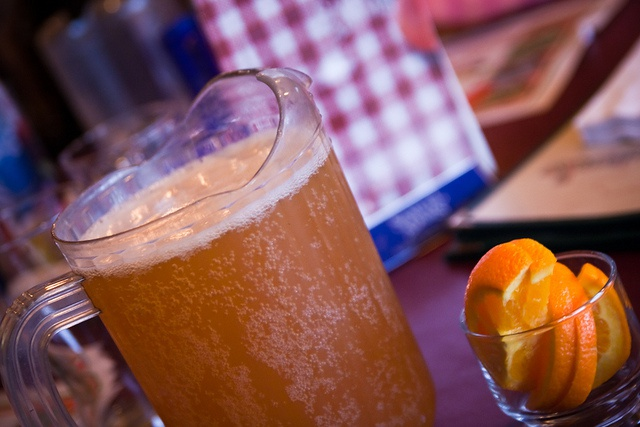Describe the objects in this image and their specific colors. I can see cup in black, maroon, brown, and lightpink tones, bowl in black, maroon, red, and brown tones, dining table in black, purple, and maroon tones, orange in black, orange, red, maroon, and brown tones, and orange in black, maroon, red, and brown tones in this image. 